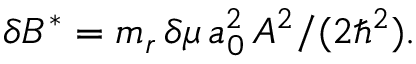Convert formula to latex. <formula><loc_0><loc_0><loc_500><loc_500>\delta B ^ { * } = m _ { r } \, \delta \mu \, a _ { 0 } ^ { 2 } \, A ^ { 2 } / ( 2 \hbar { ^ } { 2 } ) .</formula> 